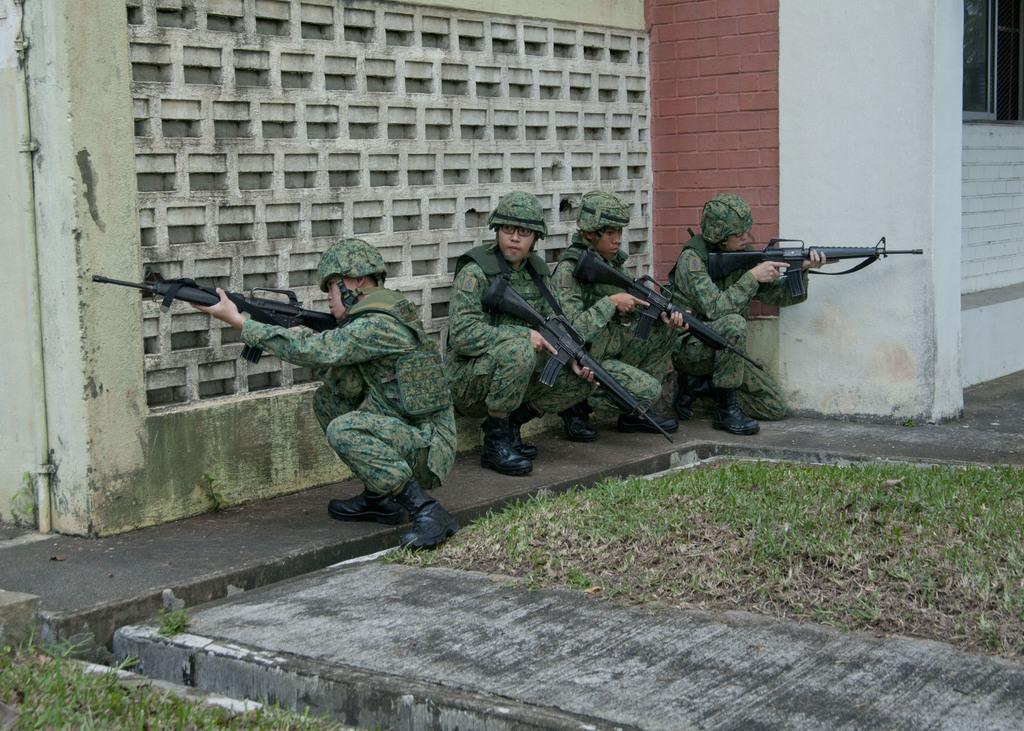How many people are present in the image? There are four people in the image. What are the people holding in their hands? The people are holding guns in their hands. Where are the people located in the image? The people are hiding near a wall. What type of building can be seen in the background of the image? There is no building visible in the image; it only shows four people hiding near a wall. 